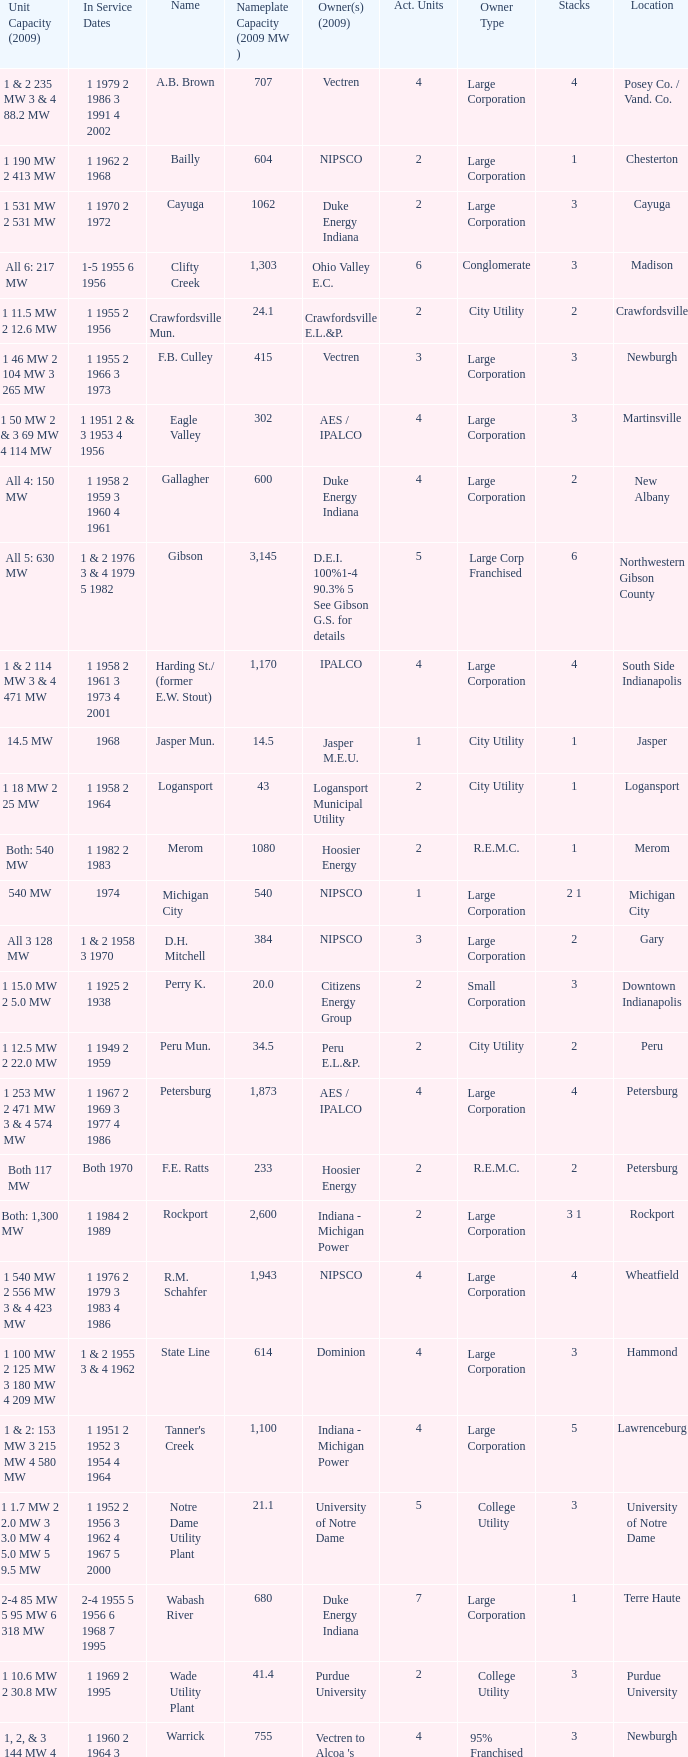Name the number of stacks for 1 & 2 235 mw 3 & 4 88.2 mw 1.0. 